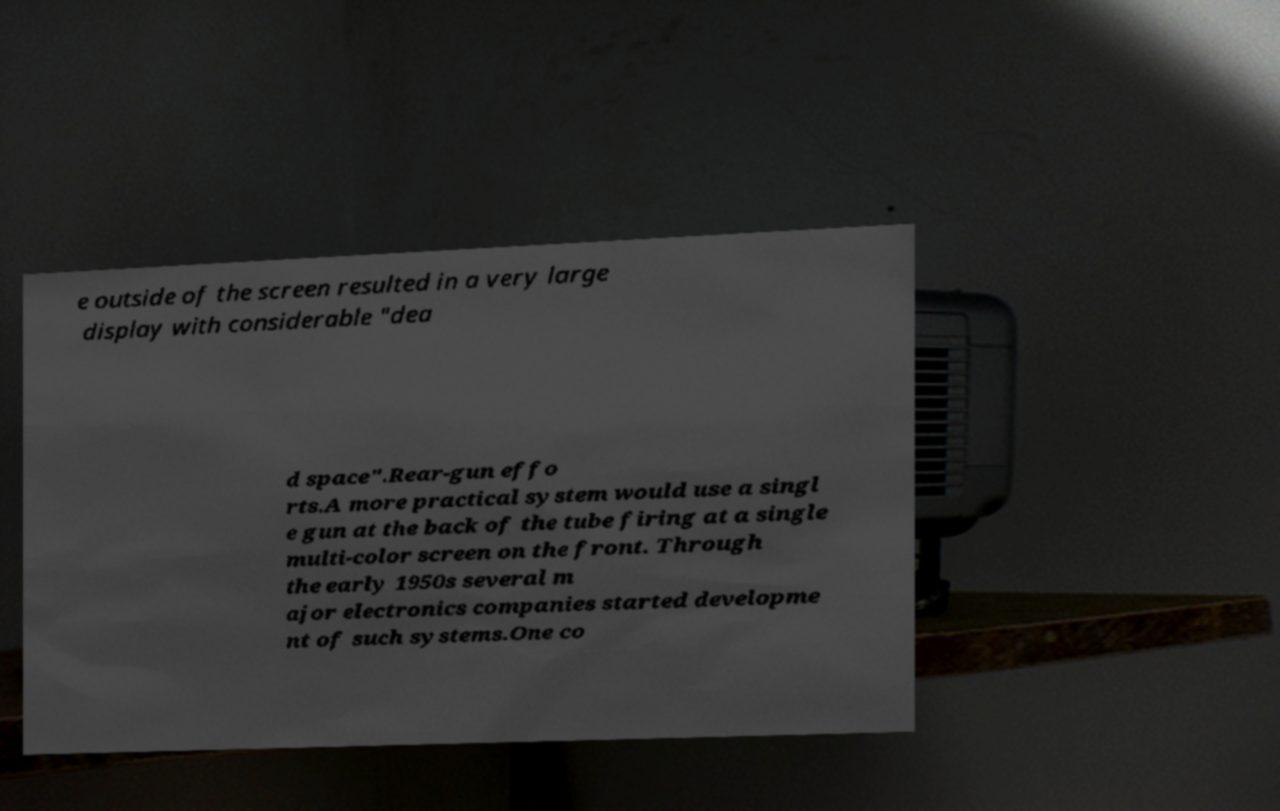Can you accurately transcribe the text from the provided image for me? e outside of the screen resulted in a very large display with considerable "dea d space".Rear-gun effo rts.A more practical system would use a singl e gun at the back of the tube firing at a single multi-color screen on the front. Through the early 1950s several m ajor electronics companies started developme nt of such systems.One co 